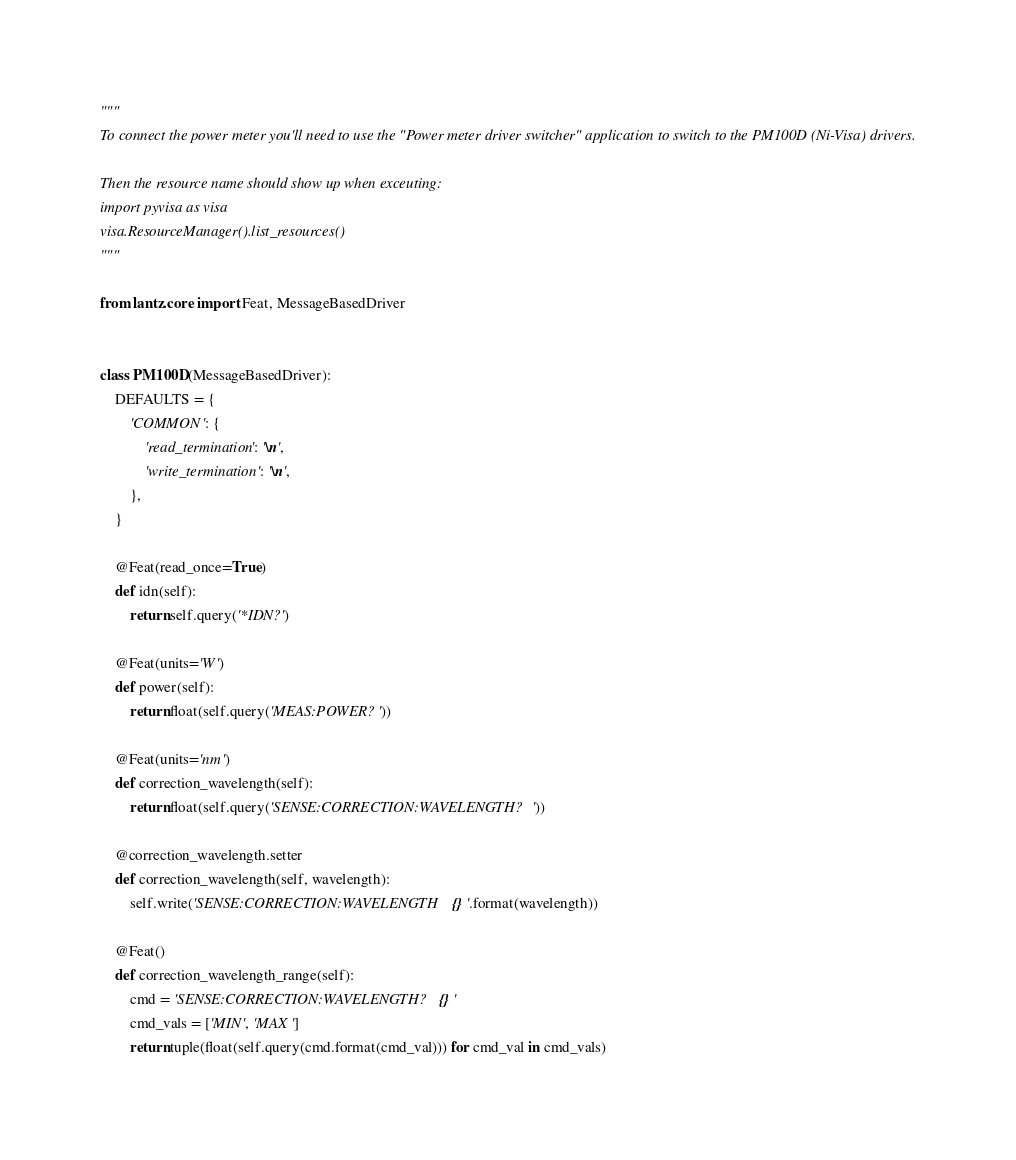Convert code to text. <code><loc_0><loc_0><loc_500><loc_500><_Python_>"""
To connect the power meter you'll need to use the "Power meter driver switcher" application to switch to the PM100D (Ni-Visa) drivers.

Then the resource name should show up when exceuting:
import pyvisa as visa
visa.ResourceManager().list_resources()
"""

from lantz.core import Feat, MessageBasedDriver


class PM100D(MessageBasedDriver):
    DEFAULTS = {
        'COMMON': {
            'read_termination': '\n',
            'write_termination': '\n',
        },
    }

    @Feat(read_once=True)
    def idn(self):
        return self.query('*IDN?')

    @Feat(units='W')
    def power(self):
        return float(self.query('MEAS:POWER?'))

    @Feat(units='nm')
    def correction_wavelength(self):
        return float(self.query('SENSE:CORRECTION:WAVELENGTH?'))

    @correction_wavelength.setter
    def correction_wavelength(self, wavelength):
        self.write('SENSE:CORRECTION:WAVELENGTH {}'.format(wavelength))

    @Feat()
    def correction_wavelength_range(self):
        cmd = 'SENSE:CORRECTION:WAVELENGTH? {}'
        cmd_vals = ['MIN', 'MAX']
        return tuple(float(self.query(cmd.format(cmd_val))) for cmd_val in cmd_vals)
</code> 